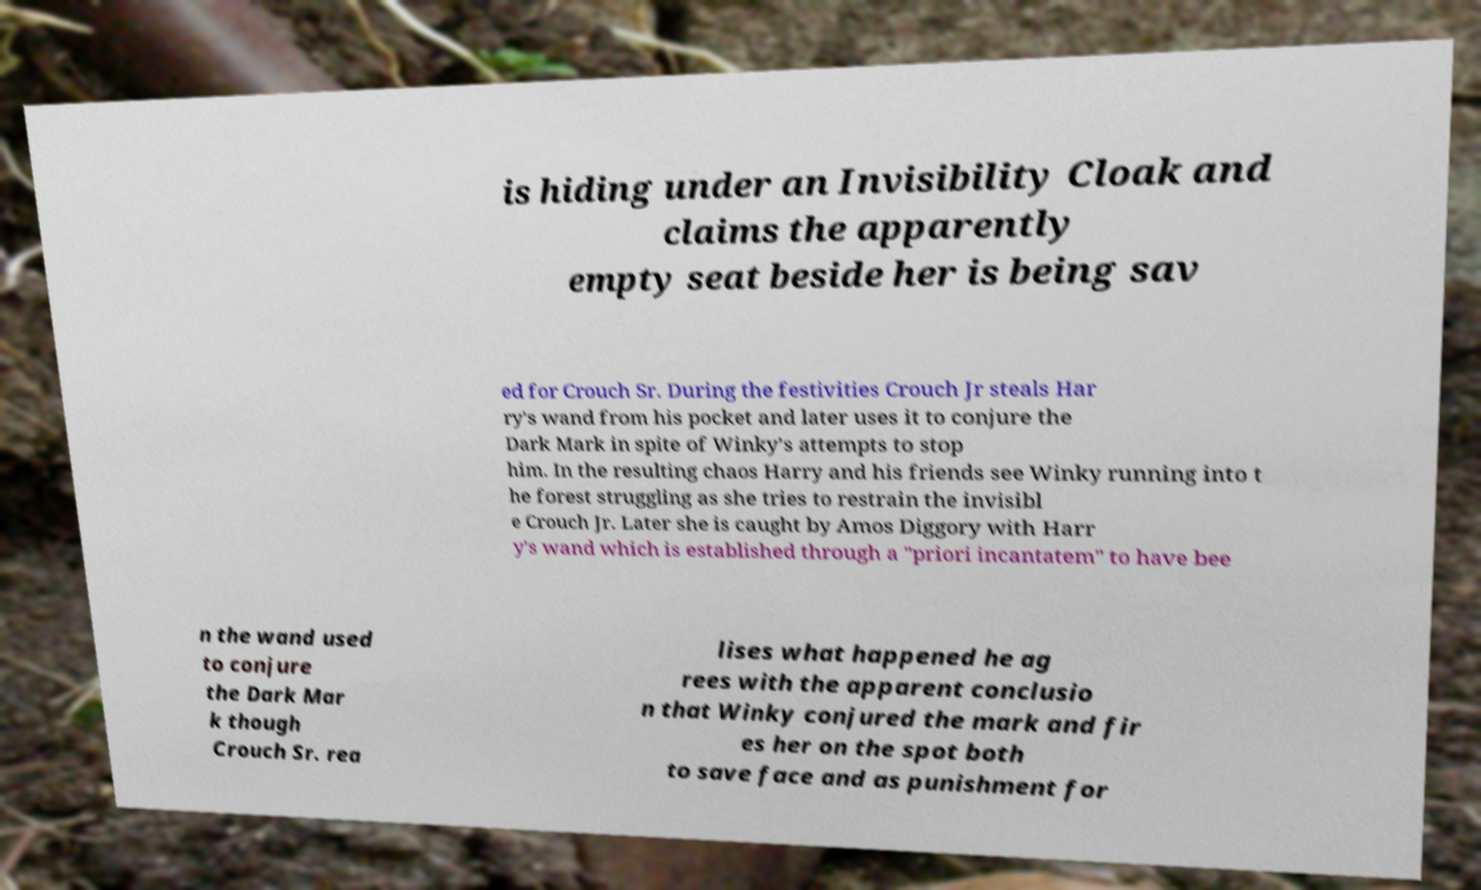Can you accurately transcribe the text from the provided image for me? is hiding under an Invisibility Cloak and claims the apparently empty seat beside her is being sav ed for Crouch Sr. During the festivities Crouch Jr steals Har ry's wand from his pocket and later uses it to conjure the Dark Mark in spite of Winky's attempts to stop him. In the resulting chaos Harry and his friends see Winky running into t he forest struggling as she tries to restrain the invisibl e Crouch Jr. Later she is caught by Amos Diggory with Harr y's wand which is established through a "priori incantatem" to have bee n the wand used to conjure the Dark Mar k though Crouch Sr. rea lises what happened he ag rees with the apparent conclusio n that Winky conjured the mark and fir es her on the spot both to save face and as punishment for 